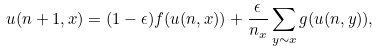<formula> <loc_0><loc_0><loc_500><loc_500>u ( n + 1 , x ) = ( 1 - \epsilon ) f ( u ( n , x ) ) + \frac { \epsilon } { n _ { x } } \sum _ { y \sim x } g ( u ( n , y ) ) ,</formula> 